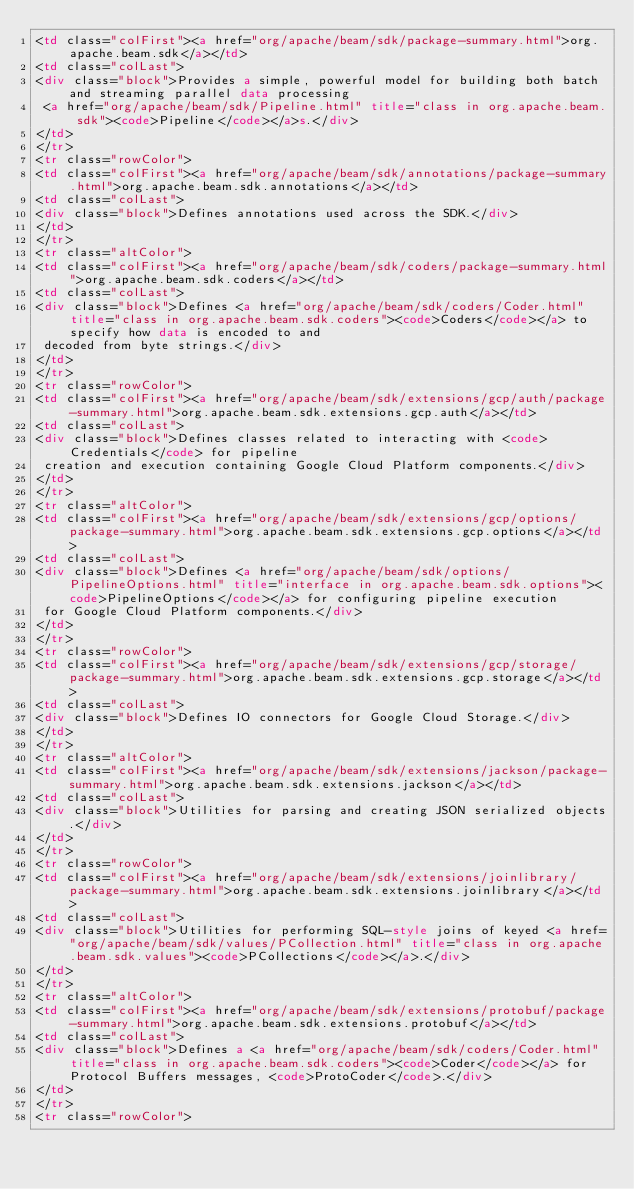Convert code to text. <code><loc_0><loc_0><loc_500><loc_500><_HTML_><td class="colFirst"><a href="org/apache/beam/sdk/package-summary.html">org.apache.beam.sdk</a></td>
<td class="colLast">
<div class="block">Provides a simple, powerful model for building both batch and streaming parallel data processing
 <a href="org/apache/beam/sdk/Pipeline.html" title="class in org.apache.beam.sdk"><code>Pipeline</code></a>s.</div>
</td>
</tr>
<tr class="rowColor">
<td class="colFirst"><a href="org/apache/beam/sdk/annotations/package-summary.html">org.apache.beam.sdk.annotations</a></td>
<td class="colLast">
<div class="block">Defines annotations used across the SDK.</div>
</td>
</tr>
<tr class="altColor">
<td class="colFirst"><a href="org/apache/beam/sdk/coders/package-summary.html">org.apache.beam.sdk.coders</a></td>
<td class="colLast">
<div class="block">Defines <a href="org/apache/beam/sdk/coders/Coder.html" title="class in org.apache.beam.sdk.coders"><code>Coders</code></a> to specify how data is encoded to and
 decoded from byte strings.</div>
</td>
</tr>
<tr class="rowColor">
<td class="colFirst"><a href="org/apache/beam/sdk/extensions/gcp/auth/package-summary.html">org.apache.beam.sdk.extensions.gcp.auth</a></td>
<td class="colLast">
<div class="block">Defines classes related to interacting with <code>Credentials</code> for pipeline
 creation and execution containing Google Cloud Platform components.</div>
</td>
</tr>
<tr class="altColor">
<td class="colFirst"><a href="org/apache/beam/sdk/extensions/gcp/options/package-summary.html">org.apache.beam.sdk.extensions.gcp.options</a></td>
<td class="colLast">
<div class="block">Defines <a href="org/apache/beam/sdk/options/PipelineOptions.html" title="interface in org.apache.beam.sdk.options"><code>PipelineOptions</code></a> for configuring pipeline execution
 for Google Cloud Platform components.</div>
</td>
</tr>
<tr class="rowColor">
<td class="colFirst"><a href="org/apache/beam/sdk/extensions/gcp/storage/package-summary.html">org.apache.beam.sdk.extensions.gcp.storage</a></td>
<td class="colLast">
<div class="block">Defines IO connectors for Google Cloud Storage.</div>
</td>
</tr>
<tr class="altColor">
<td class="colFirst"><a href="org/apache/beam/sdk/extensions/jackson/package-summary.html">org.apache.beam.sdk.extensions.jackson</a></td>
<td class="colLast">
<div class="block">Utilities for parsing and creating JSON serialized objects.</div>
</td>
</tr>
<tr class="rowColor">
<td class="colFirst"><a href="org/apache/beam/sdk/extensions/joinlibrary/package-summary.html">org.apache.beam.sdk.extensions.joinlibrary</a></td>
<td class="colLast">
<div class="block">Utilities for performing SQL-style joins of keyed <a href="org/apache/beam/sdk/values/PCollection.html" title="class in org.apache.beam.sdk.values"><code>PCollections</code></a>.</div>
</td>
</tr>
<tr class="altColor">
<td class="colFirst"><a href="org/apache/beam/sdk/extensions/protobuf/package-summary.html">org.apache.beam.sdk.extensions.protobuf</a></td>
<td class="colLast">
<div class="block">Defines a <a href="org/apache/beam/sdk/coders/Coder.html" title="class in org.apache.beam.sdk.coders"><code>Coder</code></a> for Protocol Buffers messages, <code>ProtoCoder</code>.</div>
</td>
</tr>
<tr class="rowColor"></code> 